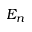Convert formula to latex. <formula><loc_0><loc_0><loc_500><loc_500>E _ { n }</formula> 